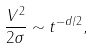<formula> <loc_0><loc_0><loc_500><loc_500>\frac { V ^ { 2 } } { 2 \sigma } \sim t ^ { - d / 2 } ,</formula> 